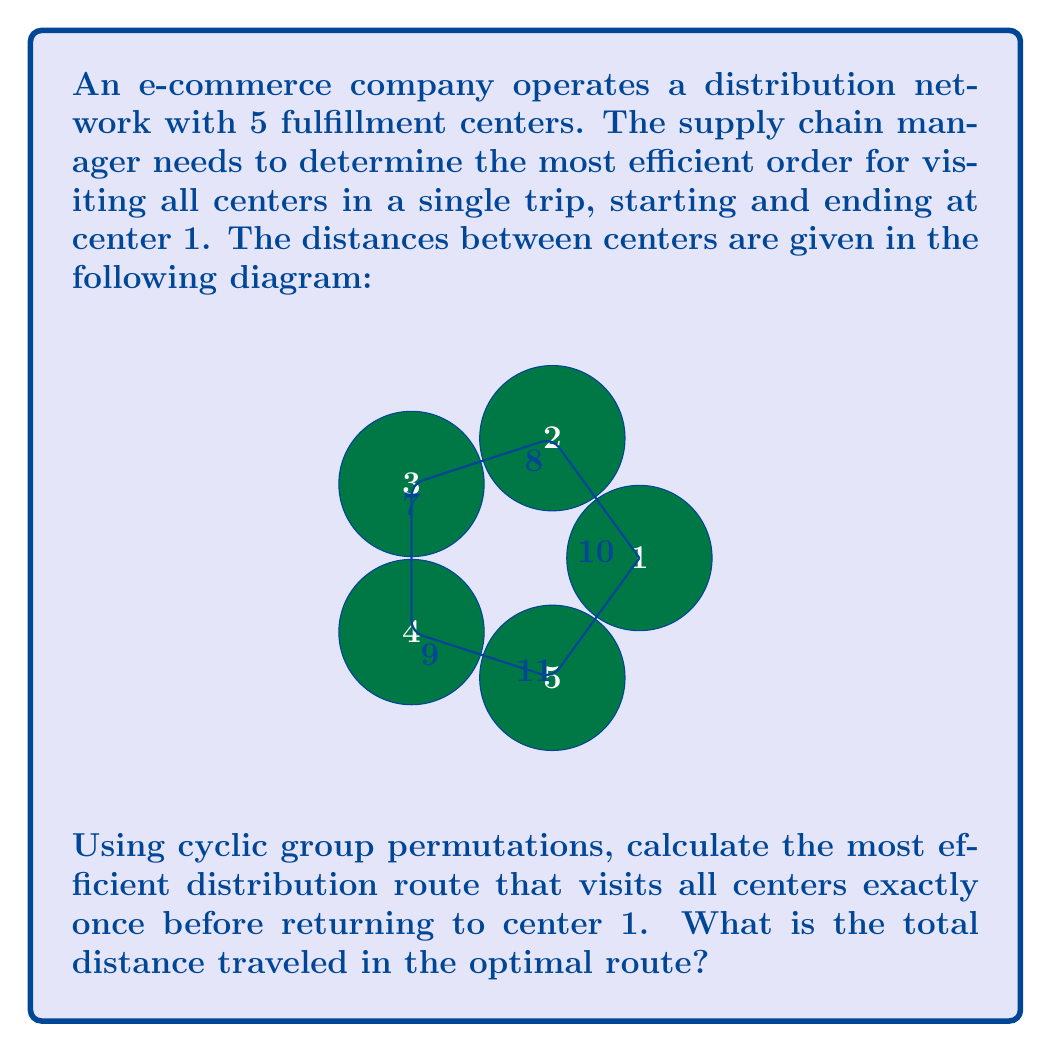Solve this math problem. To solve this problem, we'll use cyclic group permutations to generate all possible routes and calculate their total distances. Here's the step-by-step process:

1) First, we note that all routes start and end at center 1, so we only need to permute centers 2, 3, 4, and 5.

2) The cyclic group $C_4$ generates the following permutations:
   $$(2,3,4,5), (3,4,5,2), (4,5,2,3), (5,2,3,4)$$

3) For each permutation, we calculate the total distance:

   a) $(1,2,3,4,5,1)$:
      $10 + 8 + 7 + 9 + 11 = 45$

   b) $(1,3,4,5,2,1)$:
      $18 + 7 + 9 + 10 + 11 = 55$

   c) $(1,4,5,2,3,1)$:
      $25 + 9 + 10 + 8 + 18 = 70$

   d) $(1,5,2,3,4,1)$:
      $11 + 10 + 8 + 7 + 25 = 61$

4) The shortest distance is 45, corresponding to the route $(1,2,3,4,5,1)$.

5) This can be verified by checking that no other permutation of the centers yields a shorter total distance.

Therefore, the most efficient distribution route is 1 → 2 → 3 → 4 → 5 → 1, with a total distance of 45 units.
Answer: 45 units 